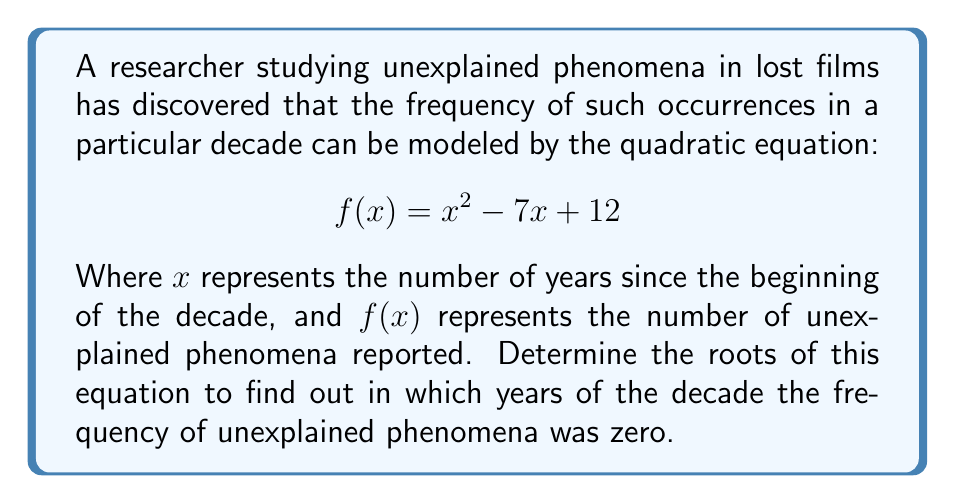Could you help me with this problem? To find the roots of the quadratic equation, we need to solve for $f(x) = 0$:

$$x^2 - 7x + 12 = 0$$

We can solve this using the quadratic formula: $x = \frac{-b \pm \sqrt{b^2 - 4ac}}{2a}$

Where $a = 1$, $b = -7$, and $c = 12$

Substituting these values into the quadratic formula:

$$x = \frac{-(-7) \pm \sqrt{(-7)^2 - 4(1)(12)}}{2(1)}$$

$$x = \frac{7 \pm \sqrt{49 - 48}}{2}$$

$$x = \frac{7 \pm \sqrt{1}}{2}$$

$$x = \frac{7 \pm 1}{2}$$

This gives us two solutions:

$$x_1 = \frac{7 + 1}{2} = \frac{8}{2} = 4$$

$$x_2 = \frac{7 - 1}{2} = \frac{6}{2} = 3$$

These roots represent the years within the decade when the frequency of unexplained phenomena was zero. Since $x$ represents the number of years since the beginning of the decade, the roots correspond to the 4th and 3rd years of the decade.
Answer: The roots of the equation are $x = 3$ and $x = 4$, corresponding to the 3rd and 4th years of the decade. 